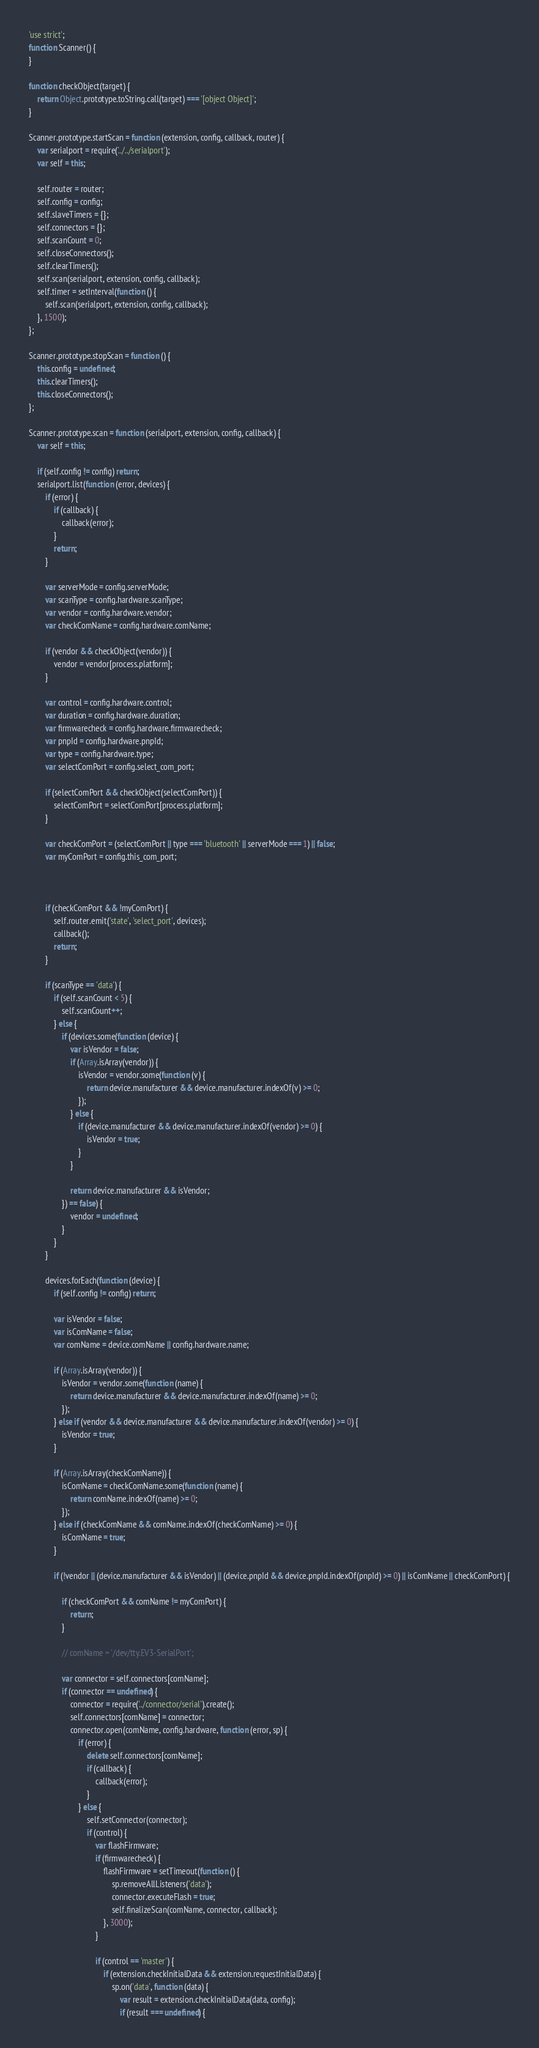Convert code to text. <code><loc_0><loc_0><loc_500><loc_500><_JavaScript_>'use strict';
function Scanner() {
}

function checkObject(target) {
	return Object.prototype.toString.call(target) === '[object Object]';
}

Scanner.prototype.startScan = function (extension, config, callback, router) {
	var serialport = require('../../serialport');
	var self = this;

	self.router = router;
	self.config = config;
	self.slaveTimers = {};
	self.connectors = {};
	self.scanCount = 0;
	self.closeConnectors();
	self.clearTimers();
	self.scan(serialport, extension, config, callback);
	self.timer = setInterval(function () {
		self.scan(serialport, extension, config, callback);
	}, 1500);
};

Scanner.prototype.stopScan = function () {
	this.config = undefined;
	this.clearTimers();
	this.closeConnectors();
};

Scanner.prototype.scan = function (serialport, extension, config, callback) {
	var self = this;

	if (self.config != config) return;
	serialport.list(function (error, devices) {
		if (error) {
			if (callback) {
				callback(error);
			}
			return;
		}

		var serverMode = config.serverMode;
		var scanType = config.hardware.scanType;
		var vendor = config.hardware.vendor;
		var checkComName = config.hardware.comName;

		if (vendor && checkObject(vendor)) {
			vendor = vendor[process.platform];
		}

		var control = config.hardware.control;
		var duration = config.hardware.duration;
		var firmwarecheck = config.hardware.firmwarecheck;
		var pnpId = config.hardware.pnpId;
		var type = config.hardware.type;
		var selectComPort = config.select_com_port;

		if (selectComPort && checkObject(selectComPort)) {
			selectComPort = selectComPort[process.platform];
		}

		var checkComPort = (selectComPort || type === 'bluetooth' || serverMode === 1) || false;
		var myComPort = config.this_com_port;



		if (checkComPort && !myComPort) {
			self.router.emit('state', 'select_port', devices);
			callback();
			return;
		}

		if (scanType == 'data') {
			if (self.scanCount < 5) {
				self.scanCount++;
			} else {
				if (devices.some(function (device) {
					var isVendor = false;
					if (Array.isArray(vendor)) {
						isVendor = vendor.some(function (v) {
							return device.manufacturer && device.manufacturer.indexOf(v) >= 0;
						});
					} else {
						if (device.manufacturer && device.manufacturer.indexOf(vendor) >= 0) {
							isVendor = true;
						}
					}

					return device.manufacturer && isVendor;
				}) == false) {
					vendor = undefined;
				}
			}
		}

		devices.forEach(function (device) {
			if (self.config != config) return;

			var isVendor = false;
			var isComName = false;
			var comName = device.comName || config.hardware.name;

			if (Array.isArray(vendor)) {
				isVendor = vendor.some(function (name) {
					return device.manufacturer && device.manufacturer.indexOf(name) >= 0;
				});
			} else if (vendor && device.manufacturer && device.manufacturer.indexOf(vendor) >= 0) {
				isVendor = true;
			}

			if (Array.isArray(checkComName)) {
				isComName = checkComName.some(function (name) {
					return comName.indexOf(name) >= 0;
				});
			} else if (checkComName && comName.indexOf(checkComName) >= 0) {
				isComName = true;
			}

			if (!vendor || (device.manufacturer && isVendor) || (device.pnpId && device.pnpId.indexOf(pnpId) >= 0) || isComName || checkComPort) {

				if (checkComPort && comName != myComPort) {
					return;
				}

				// comName = '/dev/tty.EV3-SerialPort';

				var connector = self.connectors[comName];
				if (connector == undefined) {
					connector = require('../connector/serial').create();
					self.connectors[comName] = connector;
					connector.open(comName, config.hardware, function (error, sp) {
						if (error) {
							delete self.connectors[comName];
							if (callback) {
								callback(error);
							}
						} else {
							self.setConnector(connector);
							if (control) {
								var flashFirmware;
								if (firmwarecheck) {
									flashFirmware = setTimeout(function () {
										sp.removeAllListeners('data');
										connector.executeFlash = true;
										self.finalizeScan(comName, connector, callback);
									}, 3000);
								}

								if (control == 'master') {
									if (extension.checkInitialData && extension.requestInitialData) {
										sp.on('data', function (data) {
											var result = extension.checkInitialData(data, config);
											if (result === undefined) {</code> 